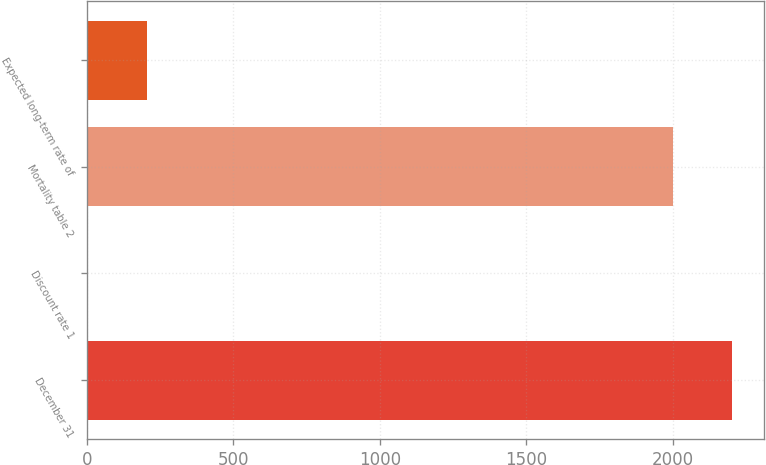Convert chart to OTSL. <chart><loc_0><loc_0><loc_500><loc_500><bar_chart><fcel>December 31<fcel>Discount rate 1<fcel>Mortality table 2<fcel>Expected long-term rate of<nl><fcel>2200.46<fcel>5.4<fcel>2000<fcel>205.86<nl></chart> 